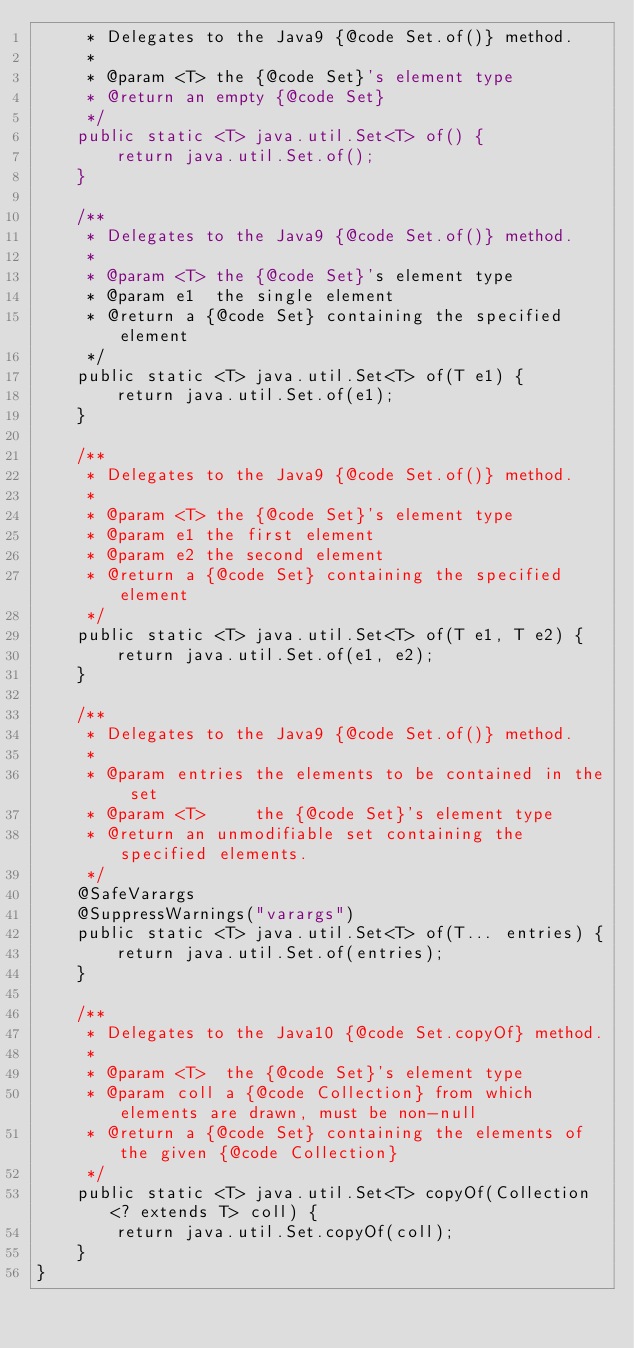Convert code to text. <code><loc_0><loc_0><loc_500><loc_500><_Java_>     * Delegates to the Java9 {@code Set.of()} method.
     *
     * @param <T> the {@code Set}'s element type
     * @return an empty {@code Set}
     */
    public static <T> java.util.Set<T> of() {
        return java.util.Set.of();
    }

    /**
     * Delegates to the Java9 {@code Set.of()} method.
     *
     * @param <T> the {@code Set}'s element type
     * @param e1  the single element
     * @return a {@code Set} containing the specified element
     */
    public static <T> java.util.Set<T> of(T e1) {
        return java.util.Set.of(e1);
    }

    /**
     * Delegates to the Java9 {@code Set.of()} method.
     *
     * @param <T> the {@code Set}'s element type
     * @param e1 the first element
     * @param e2 the second element
     * @return a {@code Set} containing the specified element
     */
    public static <T> java.util.Set<T> of(T e1, T e2) {
        return java.util.Set.of(e1, e2);
    }

    /**
     * Delegates to the Java9 {@code Set.of()} method.
     *
     * @param entries the elements to be contained in the set
     * @param <T>     the {@code Set}'s element type
     * @return an unmodifiable set containing the specified elements.
     */
    @SafeVarargs
    @SuppressWarnings("varargs")
    public static <T> java.util.Set<T> of(T... entries) {
        return java.util.Set.of(entries);
    }

    /**
     * Delegates to the Java10 {@code Set.copyOf} method.
     *
     * @param <T>  the {@code Set}'s element type
     * @param coll a {@code Collection} from which elements are drawn, must be non-null
     * @return a {@code Set} containing the elements of the given {@code Collection}
     */
    public static <T> java.util.Set<T> copyOf(Collection<? extends T> coll) {
        return java.util.Set.copyOf(coll);
    }
}
</code> 